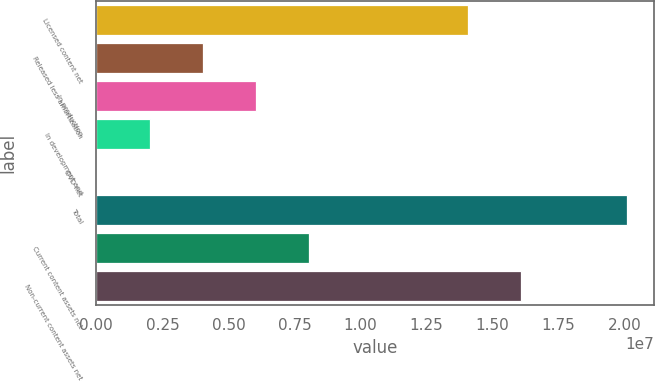Convert chart. <chart><loc_0><loc_0><loc_500><loc_500><bar_chart><fcel>Licensed content net<fcel>Released less amortization<fcel>In production<fcel>In development and<fcel>DVD net<fcel>Total<fcel>Current content assets net<fcel>Non-current content assets net<nl><fcel>1.40815e+07<fcel>4.03028e+06<fcel>6.04051e+06<fcel>2.02005e+06<fcel>9813<fcel>2.01121e+07<fcel>8.05074e+06<fcel>1.60917e+07<nl></chart> 